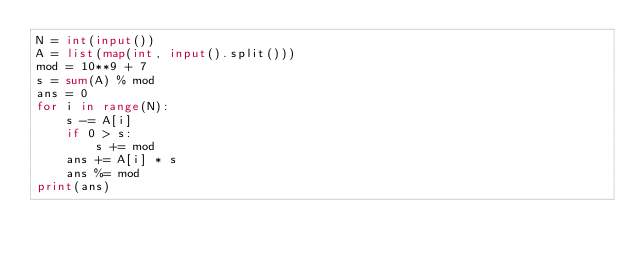Convert code to text. <code><loc_0><loc_0><loc_500><loc_500><_Python_>N = int(input())
A = list(map(int, input().split()))
mod = 10**9 + 7
s = sum(A) % mod
ans = 0
for i in range(N):
    s -= A[i]
    if 0 > s:
        s += mod
    ans += A[i] * s
    ans %= mod
print(ans)</code> 